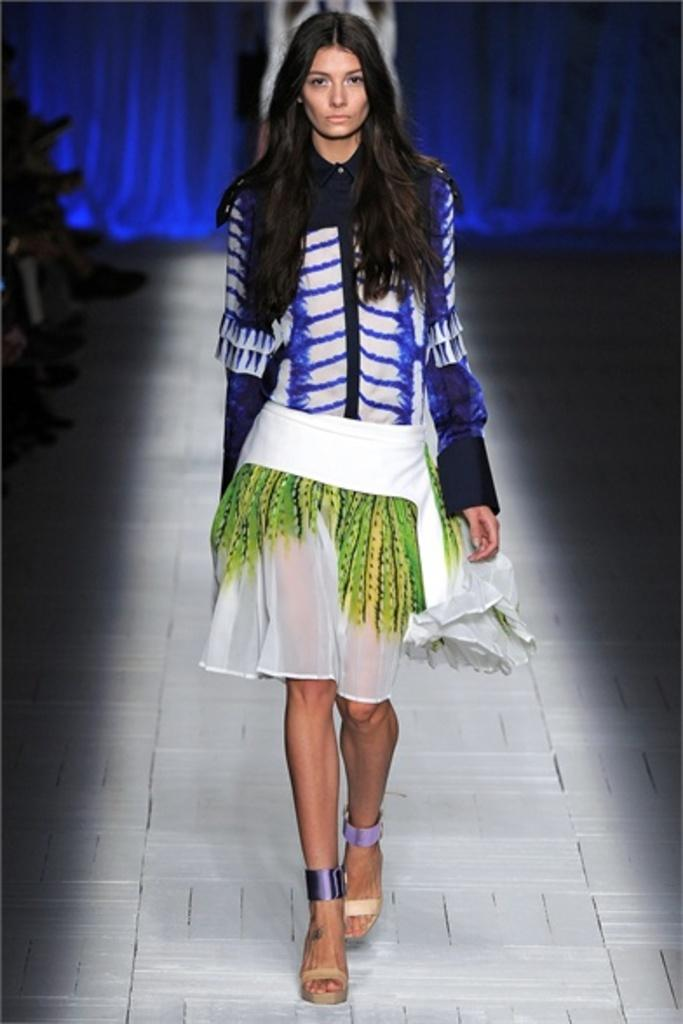Who is the main subject in the image? There is a woman in the image. What is the woman wearing? The woman is wearing a purple top and green bottom. What is the woman doing in the image? The woman is walking on a ramp. What can be seen in the background of the image? There is a violet curtain in the background of the image. What type of creature is causing the woman to lose her balance on the ramp? There is no creature present in the image, and the woman does not appear to be losing her balance. 